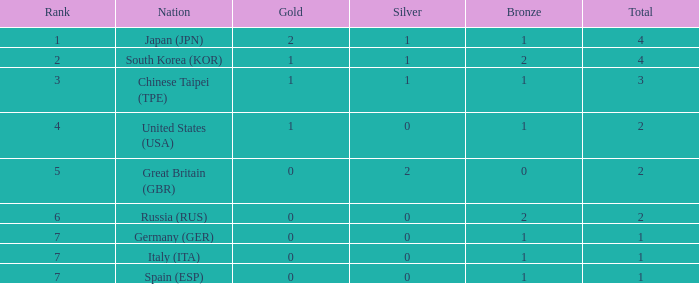What is the overall number of medals for a nation with over 1 silver medals? 2.0. Help me parse the entirety of this table. {'header': ['Rank', 'Nation', 'Gold', 'Silver', 'Bronze', 'Total'], 'rows': [['1', 'Japan (JPN)', '2', '1', '1', '4'], ['2', 'South Korea (KOR)', '1', '1', '2', '4'], ['3', 'Chinese Taipei (TPE)', '1', '1', '1', '3'], ['4', 'United States (USA)', '1', '0', '1', '2'], ['5', 'Great Britain (GBR)', '0', '2', '0', '2'], ['6', 'Russia (RUS)', '0', '0', '2', '2'], ['7', 'Germany (GER)', '0', '0', '1', '1'], ['7', 'Italy (ITA)', '0', '0', '1', '1'], ['7', 'Spain (ESP)', '0', '0', '1', '1']]} 